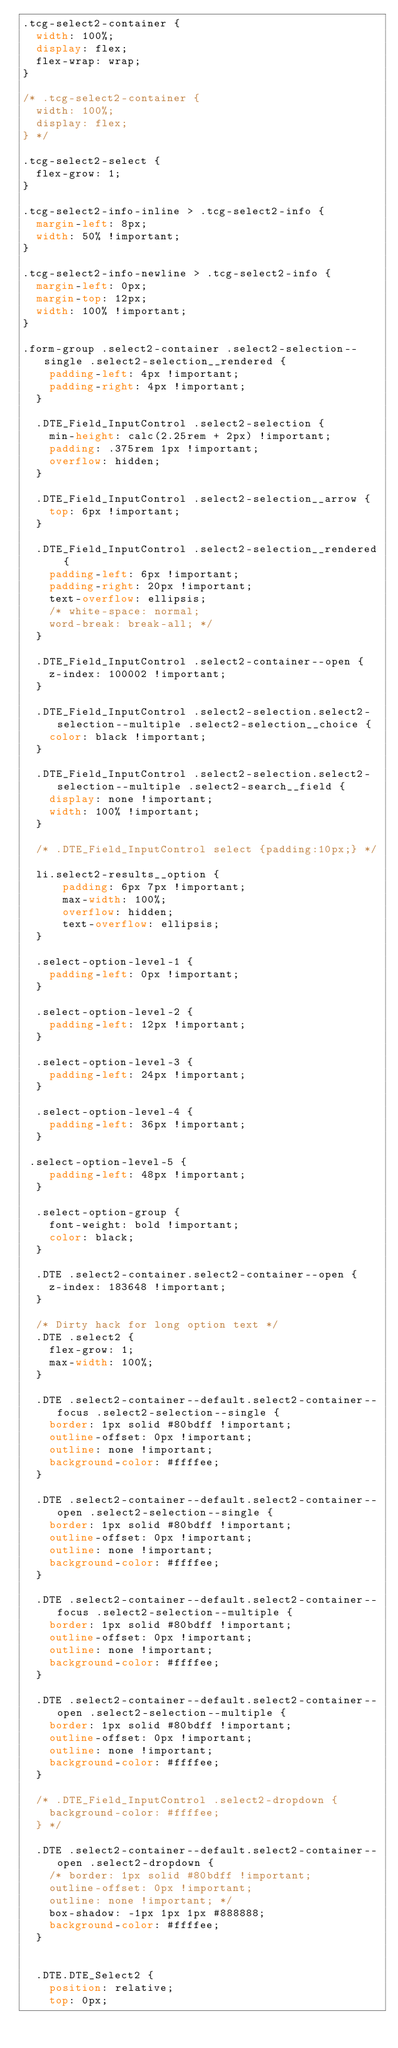<code> <loc_0><loc_0><loc_500><loc_500><_CSS_>.tcg-select2-container {
  width: 100%;
  display: flex;
  flex-wrap: wrap;
}

/* .tcg-select2-container {
  width: 100%;
  display: flex;
} */

.tcg-select2-select {
  flex-grow: 1;
}

.tcg-select2-info-inline > .tcg-select2-info {
  margin-left: 8px;
  width: 50% !important;
}

.tcg-select2-info-newline > .tcg-select2-info {
  margin-left: 0px;
  margin-top: 12px;
  width: 100% !important;
}

.form-group .select2-container .select2-selection--single .select2-selection__rendered {
    padding-left: 4px !important;
    padding-right: 4px !important;  
  }

  .DTE_Field_InputControl .select2-selection {
    min-height: calc(2.25rem + 2px) !important;
    padding: .375rem 1px !important;
    overflow: hidden;
  }

  .DTE_Field_InputControl .select2-selection__arrow {
    top: 6px !important;
  }
  
  .DTE_Field_InputControl .select2-selection__rendered {
    padding-left: 6px !important;
    padding-right: 20px !important;  
    text-overflow: ellipsis; 
    /* white-space: normal; 
    word-break: break-all; */
  }

  .DTE_Field_InputControl .select2-container--open {
    z-index: 100002 !important;
  }

  .DTE_Field_InputControl .select2-selection.select2-selection--multiple .select2-selection__choice {
    color: black !important;
  }
 
  .DTE_Field_InputControl .select2-selection.select2-selection--multiple .select2-search__field {
    display: none !important;
    width: 100% !important;
  }
  
  /* .DTE_Field_InputControl select {padding:10px;} */

  li.select2-results__option {
      padding: 6px 7px !important;
      max-width: 100%;
      overflow: hidden;
      text-overflow: ellipsis; 
  }

  .select-option-level-1 {
    padding-left: 0px !important;
  }

  .select-option-level-2 {
    padding-left: 12px !important;
  }

  .select-option-level-3 {
    padding-left: 24px !important;
  }

  .select-option-level-4 {
    padding-left: 36px !important;
  }

 .select-option-level-5 {
    padding-left: 48px !important;
  }

  .select-option-group {
    font-weight: bold !important;
    color: black;
  }

  .DTE .select2-container.select2-container--open {
    z-index: 183648 !important;
  }

  /* Dirty hack for long option text */
  .DTE .select2 {
    flex-grow: 1;
    max-width: 100%;
  }

  .DTE .select2-container--default.select2-container--focus .select2-selection--single {
    border: 1px solid #80bdff !important;
    outline-offset: 0px !important;
    outline: none !important;
    background-color: #ffffee;
  }

  .DTE .select2-container--default.select2-container--open .select2-selection--single {
    border: 1px solid #80bdff !important;
    outline-offset: 0px !important;
    outline: none !important;
    background-color: #ffffee;
  }

  .DTE .select2-container--default.select2-container--focus .select2-selection--multiple {
    border: 1px solid #80bdff !important;
    outline-offset: 0px !important;
    outline: none !important;
    background-color: #ffffee;
  }

  .DTE .select2-container--default.select2-container--open .select2-selection--multiple {
    border: 1px solid #80bdff !important;
    outline-offset: 0px !important;
    outline: none !important;
    background-color: #ffffee;
  }

  /* .DTE_Field_InputControl .select2-dropdown {
    background-color: #ffffee;
  } */

  .DTE .select2-container--default.select2-container--open .select2-dropdown {
    /* border: 1px solid #80bdff !important;
    outline-offset: 0px !important;
    outline: none !important; */
    box-shadow: -1px 1px 1px #888888;
    background-color: #ffffee;
  }

    
  .DTE.DTE_Select2 {
    position: relative;
    top: 0px;</code> 